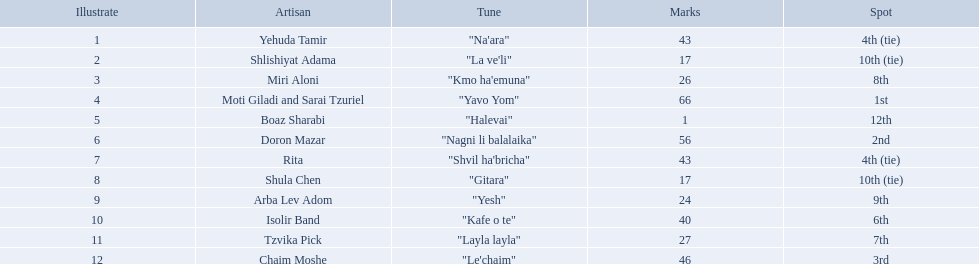Could you parse the entire table? {'header': ['Illustrate', 'Artisan', 'Tune', 'Marks', 'Spot'], 'rows': [['1', 'Yehuda Tamir', '"Na\'ara"', '43', '4th (tie)'], ['2', 'Shlishiyat Adama', '"La ve\'li"', '17', '10th (tie)'], ['3', 'Miri Aloni', '"Kmo ha\'emuna"', '26', '8th'], ['4', 'Moti Giladi and Sarai Tzuriel', '"Yavo Yom"', '66', '1st'], ['5', 'Boaz Sharabi', '"Halevai"', '1', '12th'], ['6', 'Doron Mazar', '"Nagni li balalaika"', '56', '2nd'], ['7', 'Rita', '"Shvil ha\'bricha"', '43', '4th (tie)'], ['8', 'Shula Chen', '"Gitara"', '17', '10th (tie)'], ['9', 'Arba Lev Adom', '"Yesh"', '24', '9th'], ['10', 'Isolir Band', '"Kafe o te"', '40', '6th'], ['11', 'Tzvika Pick', '"Layla layla"', '27', '7th'], ['12', 'Chaim Moshe', '"Le\'chaim"', '46', '3rd']]} What is the place of the contestant who received only 1 point? 12th. What is the name of the artist listed in the previous question? Boaz Sharabi. Who are all of the artists? Yehuda Tamir, Shlishiyat Adama, Miri Aloni, Moti Giladi and Sarai Tzuriel, Boaz Sharabi, Doron Mazar, Rita, Shula Chen, Arba Lev Adom, Isolir Band, Tzvika Pick, Chaim Moshe. How many points did each score? 43, 17, 26, 66, 1, 56, 43, 17, 24, 40, 27, 46. And which artist had the least amount of points? Boaz Sharabi. 